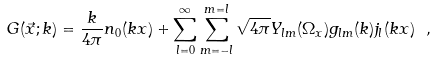Convert formula to latex. <formula><loc_0><loc_0><loc_500><loc_500>G ( \vec { x } ; k ) = \frac { k } { 4 \pi } n _ { 0 } ( k x ) + \sum _ { l = 0 } ^ { \infty } \sum _ { m = - l } ^ { m = l } \sqrt { 4 \pi } Y _ { l m } ( \Omega _ { x } ) g _ { l m } ( k ) j _ { l } ( k x ) \ ,</formula> 